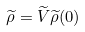<formula> <loc_0><loc_0><loc_500><loc_500>\widetilde { \rho } = \widetilde { V } \widetilde { \rho } ( 0 )</formula> 